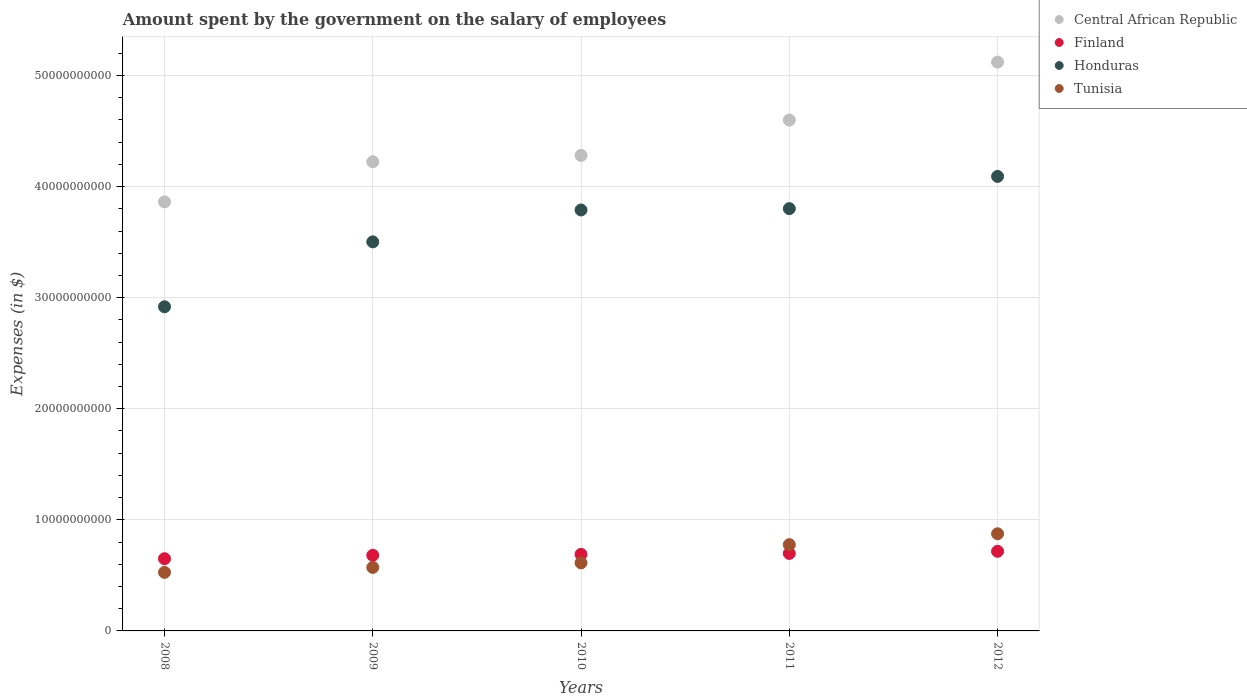How many different coloured dotlines are there?
Provide a succinct answer. 4. Is the number of dotlines equal to the number of legend labels?
Give a very brief answer. Yes. What is the amount spent on the salary of employees by the government in Tunisia in 2011?
Your answer should be very brief. 7.77e+09. Across all years, what is the maximum amount spent on the salary of employees by the government in Tunisia?
Your answer should be very brief. 8.75e+09. Across all years, what is the minimum amount spent on the salary of employees by the government in Honduras?
Your response must be concise. 2.92e+1. In which year was the amount spent on the salary of employees by the government in Tunisia maximum?
Keep it short and to the point. 2012. In which year was the amount spent on the salary of employees by the government in Central African Republic minimum?
Your answer should be compact. 2008. What is the total amount spent on the salary of employees by the government in Central African Republic in the graph?
Offer a very short reply. 2.21e+11. What is the difference between the amount spent on the salary of employees by the government in Finland in 2008 and that in 2012?
Offer a terse response. -6.66e+08. What is the difference between the amount spent on the salary of employees by the government in Finland in 2012 and the amount spent on the salary of employees by the government in Tunisia in 2010?
Offer a terse response. 1.04e+09. What is the average amount spent on the salary of employees by the government in Finland per year?
Your answer should be compact. 6.87e+09. In the year 2009, what is the difference between the amount spent on the salary of employees by the government in Central African Republic and amount spent on the salary of employees by the government in Tunisia?
Offer a very short reply. 3.65e+1. In how many years, is the amount spent on the salary of employees by the government in Finland greater than 14000000000 $?
Provide a succinct answer. 0. What is the ratio of the amount spent on the salary of employees by the government in Honduras in 2008 to that in 2009?
Your response must be concise. 0.83. Is the amount spent on the salary of employees by the government in Honduras in 2009 less than that in 2010?
Give a very brief answer. Yes. Is the difference between the amount spent on the salary of employees by the government in Central African Republic in 2008 and 2012 greater than the difference between the amount spent on the salary of employees by the government in Tunisia in 2008 and 2012?
Offer a terse response. No. What is the difference between the highest and the second highest amount spent on the salary of employees by the government in Tunisia?
Keep it short and to the point. 9.78e+08. What is the difference between the highest and the lowest amount spent on the salary of employees by the government in Honduras?
Keep it short and to the point. 1.17e+1. Is the sum of the amount spent on the salary of employees by the government in Central African Republic in 2009 and 2012 greater than the maximum amount spent on the salary of employees by the government in Finland across all years?
Ensure brevity in your answer.  Yes. Is the amount spent on the salary of employees by the government in Finland strictly less than the amount spent on the salary of employees by the government in Central African Republic over the years?
Make the answer very short. Yes. What is the difference between two consecutive major ticks on the Y-axis?
Ensure brevity in your answer.  1.00e+1. Does the graph contain grids?
Your answer should be very brief. Yes. Where does the legend appear in the graph?
Offer a very short reply. Top right. What is the title of the graph?
Your answer should be compact. Amount spent by the government on the salary of employees. Does "Senegal" appear as one of the legend labels in the graph?
Ensure brevity in your answer.  No. What is the label or title of the Y-axis?
Offer a terse response. Expenses (in $). What is the Expenses (in $) in Central African Republic in 2008?
Keep it short and to the point. 3.86e+1. What is the Expenses (in $) of Finland in 2008?
Your answer should be very brief. 6.50e+09. What is the Expenses (in $) of Honduras in 2008?
Keep it short and to the point. 2.92e+1. What is the Expenses (in $) in Tunisia in 2008?
Provide a short and direct response. 5.27e+09. What is the Expenses (in $) of Central African Republic in 2009?
Your answer should be very brief. 4.22e+1. What is the Expenses (in $) of Finland in 2009?
Offer a very short reply. 6.81e+09. What is the Expenses (in $) in Honduras in 2009?
Give a very brief answer. 3.50e+1. What is the Expenses (in $) of Tunisia in 2009?
Provide a short and direct response. 5.72e+09. What is the Expenses (in $) of Central African Republic in 2010?
Provide a short and direct response. 4.28e+1. What is the Expenses (in $) of Finland in 2010?
Give a very brief answer. 6.89e+09. What is the Expenses (in $) in Honduras in 2010?
Your response must be concise. 3.79e+1. What is the Expenses (in $) in Tunisia in 2010?
Ensure brevity in your answer.  6.13e+09. What is the Expenses (in $) of Central African Republic in 2011?
Your answer should be compact. 4.60e+1. What is the Expenses (in $) in Finland in 2011?
Keep it short and to the point. 6.98e+09. What is the Expenses (in $) of Honduras in 2011?
Your answer should be very brief. 3.80e+1. What is the Expenses (in $) in Tunisia in 2011?
Your answer should be very brief. 7.77e+09. What is the Expenses (in $) in Central African Republic in 2012?
Offer a very short reply. 5.12e+1. What is the Expenses (in $) in Finland in 2012?
Your response must be concise. 7.17e+09. What is the Expenses (in $) in Honduras in 2012?
Your answer should be very brief. 4.09e+1. What is the Expenses (in $) of Tunisia in 2012?
Your answer should be very brief. 8.75e+09. Across all years, what is the maximum Expenses (in $) in Central African Republic?
Ensure brevity in your answer.  5.12e+1. Across all years, what is the maximum Expenses (in $) in Finland?
Give a very brief answer. 7.17e+09. Across all years, what is the maximum Expenses (in $) of Honduras?
Give a very brief answer. 4.09e+1. Across all years, what is the maximum Expenses (in $) of Tunisia?
Your answer should be compact. 8.75e+09. Across all years, what is the minimum Expenses (in $) of Central African Republic?
Provide a succinct answer. 3.86e+1. Across all years, what is the minimum Expenses (in $) of Finland?
Provide a succinct answer. 6.50e+09. Across all years, what is the minimum Expenses (in $) of Honduras?
Provide a short and direct response. 2.92e+1. Across all years, what is the minimum Expenses (in $) of Tunisia?
Offer a terse response. 5.27e+09. What is the total Expenses (in $) in Central African Republic in the graph?
Offer a very short reply. 2.21e+11. What is the total Expenses (in $) in Finland in the graph?
Your response must be concise. 3.43e+1. What is the total Expenses (in $) in Honduras in the graph?
Give a very brief answer. 1.81e+11. What is the total Expenses (in $) of Tunisia in the graph?
Your answer should be compact. 3.36e+1. What is the difference between the Expenses (in $) in Central African Republic in 2008 and that in 2009?
Your answer should be compact. -3.62e+09. What is the difference between the Expenses (in $) in Finland in 2008 and that in 2009?
Provide a short and direct response. -3.06e+08. What is the difference between the Expenses (in $) in Honduras in 2008 and that in 2009?
Your answer should be compact. -5.85e+09. What is the difference between the Expenses (in $) of Tunisia in 2008 and that in 2009?
Provide a succinct answer. -4.45e+08. What is the difference between the Expenses (in $) of Central African Republic in 2008 and that in 2010?
Your answer should be compact. -4.18e+09. What is the difference between the Expenses (in $) of Finland in 2008 and that in 2010?
Offer a very short reply. -3.93e+08. What is the difference between the Expenses (in $) of Honduras in 2008 and that in 2010?
Provide a short and direct response. -8.72e+09. What is the difference between the Expenses (in $) in Tunisia in 2008 and that in 2010?
Your answer should be compact. -8.54e+08. What is the difference between the Expenses (in $) in Central African Republic in 2008 and that in 2011?
Provide a short and direct response. -7.37e+09. What is the difference between the Expenses (in $) of Finland in 2008 and that in 2011?
Give a very brief answer. -4.76e+08. What is the difference between the Expenses (in $) in Honduras in 2008 and that in 2011?
Keep it short and to the point. -8.84e+09. What is the difference between the Expenses (in $) in Tunisia in 2008 and that in 2011?
Provide a short and direct response. -2.50e+09. What is the difference between the Expenses (in $) in Central African Republic in 2008 and that in 2012?
Keep it short and to the point. -1.26e+1. What is the difference between the Expenses (in $) in Finland in 2008 and that in 2012?
Offer a very short reply. -6.66e+08. What is the difference between the Expenses (in $) in Honduras in 2008 and that in 2012?
Ensure brevity in your answer.  -1.17e+1. What is the difference between the Expenses (in $) of Tunisia in 2008 and that in 2012?
Your response must be concise. -3.47e+09. What is the difference between the Expenses (in $) of Central African Republic in 2009 and that in 2010?
Ensure brevity in your answer.  -5.67e+08. What is the difference between the Expenses (in $) of Finland in 2009 and that in 2010?
Provide a succinct answer. -8.70e+07. What is the difference between the Expenses (in $) in Honduras in 2009 and that in 2010?
Offer a very short reply. -2.87e+09. What is the difference between the Expenses (in $) of Tunisia in 2009 and that in 2010?
Provide a short and direct response. -4.09e+08. What is the difference between the Expenses (in $) in Central African Republic in 2009 and that in 2011?
Provide a short and direct response. -3.75e+09. What is the difference between the Expenses (in $) of Finland in 2009 and that in 2011?
Keep it short and to the point. -1.70e+08. What is the difference between the Expenses (in $) in Honduras in 2009 and that in 2011?
Ensure brevity in your answer.  -2.99e+09. What is the difference between the Expenses (in $) of Tunisia in 2009 and that in 2011?
Give a very brief answer. -2.05e+09. What is the difference between the Expenses (in $) in Central African Republic in 2009 and that in 2012?
Your answer should be compact. -8.97e+09. What is the difference between the Expenses (in $) of Finland in 2009 and that in 2012?
Offer a very short reply. -3.60e+08. What is the difference between the Expenses (in $) of Honduras in 2009 and that in 2012?
Your response must be concise. -5.89e+09. What is the difference between the Expenses (in $) of Tunisia in 2009 and that in 2012?
Keep it short and to the point. -3.03e+09. What is the difference between the Expenses (in $) in Central African Republic in 2010 and that in 2011?
Ensure brevity in your answer.  -3.18e+09. What is the difference between the Expenses (in $) in Finland in 2010 and that in 2011?
Keep it short and to the point. -8.30e+07. What is the difference between the Expenses (in $) in Honduras in 2010 and that in 2011?
Make the answer very short. -1.22e+08. What is the difference between the Expenses (in $) of Tunisia in 2010 and that in 2011?
Your response must be concise. -1.64e+09. What is the difference between the Expenses (in $) of Central African Republic in 2010 and that in 2012?
Your answer should be very brief. -8.40e+09. What is the difference between the Expenses (in $) in Finland in 2010 and that in 2012?
Give a very brief answer. -2.73e+08. What is the difference between the Expenses (in $) of Honduras in 2010 and that in 2012?
Keep it short and to the point. -3.02e+09. What is the difference between the Expenses (in $) of Tunisia in 2010 and that in 2012?
Your answer should be very brief. -2.62e+09. What is the difference between the Expenses (in $) of Central African Republic in 2011 and that in 2012?
Offer a very short reply. -5.22e+09. What is the difference between the Expenses (in $) of Finland in 2011 and that in 2012?
Provide a succinct answer. -1.90e+08. What is the difference between the Expenses (in $) of Honduras in 2011 and that in 2012?
Make the answer very short. -2.90e+09. What is the difference between the Expenses (in $) of Tunisia in 2011 and that in 2012?
Give a very brief answer. -9.78e+08. What is the difference between the Expenses (in $) in Central African Republic in 2008 and the Expenses (in $) in Finland in 2009?
Provide a short and direct response. 3.18e+1. What is the difference between the Expenses (in $) in Central African Republic in 2008 and the Expenses (in $) in Honduras in 2009?
Keep it short and to the point. 3.60e+09. What is the difference between the Expenses (in $) in Central African Republic in 2008 and the Expenses (in $) in Tunisia in 2009?
Ensure brevity in your answer.  3.29e+1. What is the difference between the Expenses (in $) of Finland in 2008 and the Expenses (in $) of Honduras in 2009?
Make the answer very short. -2.85e+1. What is the difference between the Expenses (in $) in Finland in 2008 and the Expenses (in $) in Tunisia in 2009?
Your response must be concise. 7.82e+08. What is the difference between the Expenses (in $) of Honduras in 2008 and the Expenses (in $) of Tunisia in 2009?
Keep it short and to the point. 2.35e+1. What is the difference between the Expenses (in $) in Central African Republic in 2008 and the Expenses (in $) in Finland in 2010?
Provide a succinct answer. 3.17e+1. What is the difference between the Expenses (in $) of Central African Republic in 2008 and the Expenses (in $) of Honduras in 2010?
Ensure brevity in your answer.  7.27e+08. What is the difference between the Expenses (in $) in Central African Republic in 2008 and the Expenses (in $) in Tunisia in 2010?
Your response must be concise. 3.25e+1. What is the difference between the Expenses (in $) of Finland in 2008 and the Expenses (in $) of Honduras in 2010?
Provide a short and direct response. -3.14e+1. What is the difference between the Expenses (in $) of Finland in 2008 and the Expenses (in $) of Tunisia in 2010?
Offer a terse response. 3.73e+08. What is the difference between the Expenses (in $) in Honduras in 2008 and the Expenses (in $) in Tunisia in 2010?
Your answer should be very brief. 2.31e+1. What is the difference between the Expenses (in $) of Central African Republic in 2008 and the Expenses (in $) of Finland in 2011?
Offer a terse response. 3.16e+1. What is the difference between the Expenses (in $) of Central African Republic in 2008 and the Expenses (in $) of Honduras in 2011?
Keep it short and to the point. 6.05e+08. What is the difference between the Expenses (in $) of Central African Republic in 2008 and the Expenses (in $) of Tunisia in 2011?
Ensure brevity in your answer.  3.09e+1. What is the difference between the Expenses (in $) of Finland in 2008 and the Expenses (in $) of Honduras in 2011?
Ensure brevity in your answer.  -3.15e+1. What is the difference between the Expenses (in $) in Finland in 2008 and the Expenses (in $) in Tunisia in 2011?
Your response must be concise. -1.27e+09. What is the difference between the Expenses (in $) of Honduras in 2008 and the Expenses (in $) of Tunisia in 2011?
Make the answer very short. 2.14e+1. What is the difference between the Expenses (in $) of Central African Republic in 2008 and the Expenses (in $) of Finland in 2012?
Ensure brevity in your answer.  3.15e+1. What is the difference between the Expenses (in $) of Central African Republic in 2008 and the Expenses (in $) of Honduras in 2012?
Your response must be concise. -2.29e+09. What is the difference between the Expenses (in $) in Central African Republic in 2008 and the Expenses (in $) in Tunisia in 2012?
Give a very brief answer. 2.99e+1. What is the difference between the Expenses (in $) in Finland in 2008 and the Expenses (in $) in Honduras in 2012?
Offer a very short reply. -3.44e+1. What is the difference between the Expenses (in $) of Finland in 2008 and the Expenses (in $) of Tunisia in 2012?
Your answer should be very brief. -2.25e+09. What is the difference between the Expenses (in $) in Honduras in 2008 and the Expenses (in $) in Tunisia in 2012?
Offer a terse response. 2.04e+1. What is the difference between the Expenses (in $) in Central African Republic in 2009 and the Expenses (in $) in Finland in 2010?
Your answer should be compact. 3.54e+1. What is the difference between the Expenses (in $) of Central African Republic in 2009 and the Expenses (in $) of Honduras in 2010?
Ensure brevity in your answer.  4.34e+09. What is the difference between the Expenses (in $) of Central African Republic in 2009 and the Expenses (in $) of Tunisia in 2010?
Offer a terse response. 3.61e+1. What is the difference between the Expenses (in $) in Finland in 2009 and the Expenses (in $) in Honduras in 2010?
Your answer should be compact. -3.11e+1. What is the difference between the Expenses (in $) of Finland in 2009 and the Expenses (in $) of Tunisia in 2010?
Provide a succinct answer. 6.79e+08. What is the difference between the Expenses (in $) in Honduras in 2009 and the Expenses (in $) in Tunisia in 2010?
Provide a short and direct response. 2.89e+1. What is the difference between the Expenses (in $) in Central African Republic in 2009 and the Expenses (in $) in Finland in 2011?
Keep it short and to the point. 3.53e+1. What is the difference between the Expenses (in $) in Central African Republic in 2009 and the Expenses (in $) in Honduras in 2011?
Keep it short and to the point. 4.22e+09. What is the difference between the Expenses (in $) in Central African Republic in 2009 and the Expenses (in $) in Tunisia in 2011?
Offer a very short reply. 3.45e+1. What is the difference between the Expenses (in $) in Finland in 2009 and the Expenses (in $) in Honduras in 2011?
Ensure brevity in your answer.  -3.12e+1. What is the difference between the Expenses (in $) in Finland in 2009 and the Expenses (in $) in Tunisia in 2011?
Provide a short and direct response. -9.62e+08. What is the difference between the Expenses (in $) of Honduras in 2009 and the Expenses (in $) of Tunisia in 2011?
Ensure brevity in your answer.  2.73e+1. What is the difference between the Expenses (in $) in Central African Republic in 2009 and the Expenses (in $) in Finland in 2012?
Your response must be concise. 3.51e+1. What is the difference between the Expenses (in $) of Central African Republic in 2009 and the Expenses (in $) of Honduras in 2012?
Keep it short and to the point. 1.32e+09. What is the difference between the Expenses (in $) of Central African Republic in 2009 and the Expenses (in $) of Tunisia in 2012?
Offer a very short reply. 3.35e+1. What is the difference between the Expenses (in $) of Finland in 2009 and the Expenses (in $) of Honduras in 2012?
Make the answer very short. -3.41e+1. What is the difference between the Expenses (in $) of Finland in 2009 and the Expenses (in $) of Tunisia in 2012?
Your answer should be very brief. -1.94e+09. What is the difference between the Expenses (in $) of Honduras in 2009 and the Expenses (in $) of Tunisia in 2012?
Give a very brief answer. 2.63e+1. What is the difference between the Expenses (in $) in Central African Republic in 2010 and the Expenses (in $) in Finland in 2011?
Your response must be concise. 3.58e+1. What is the difference between the Expenses (in $) in Central African Republic in 2010 and the Expenses (in $) in Honduras in 2011?
Give a very brief answer. 4.79e+09. What is the difference between the Expenses (in $) in Central African Republic in 2010 and the Expenses (in $) in Tunisia in 2011?
Your answer should be very brief. 3.50e+1. What is the difference between the Expenses (in $) of Finland in 2010 and the Expenses (in $) of Honduras in 2011?
Provide a succinct answer. -3.11e+1. What is the difference between the Expenses (in $) in Finland in 2010 and the Expenses (in $) in Tunisia in 2011?
Your answer should be compact. -8.75e+08. What is the difference between the Expenses (in $) of Honduras in 2010 and the Expenses (in $) of Tunisia in 2011?
Your answer should be very brief. 3.01e+1. What is the difference between the Expenses (in $) of Central African Republic in 2010 and the Expenses (in $) of Finland in 2012?
Keep it short and to the point. 3.56e+1. What is the difference between the Expenses (in $) of Central African Republic in 2010 and the Expenses (in $) of Honduras in 2012?
Your answer should be compact. 1.89e+09. What is the difference between the Expenses (in $) of Central African Republic in 2010 and the Expenses (in $) of Tunisia in 2012?
Your answer should be compact. 3.41e+1. What is the difference between the Expenses (in $) in Finland in 2010 and the Expenses (in $) in Honduras in 2012?
Provide a short and direct response. -3.40e+1. What is the difference between the Expenses (in $) of Finland in 2010 and the Expenses (in $) of Tunisia in 2012?
Provide a short and direct response. -1.85e+09. What is the difference between the Expenses (in $) of Honduras in 2010 and the Expenses (in $) of Tunisia in 2012?
Provide a succinct answer. 2.92e+1. What is the difference between the Expenses (in $) in Central African Republic in 2011 and the Expenses (in $) in Finland in 2012?
Offer a terse response. 3.88e+1. What is the difference between the Expenses (in $) of Central African Republic in 2011 and the Expenses (in $) of Honduras in 2012?
Offer a very short reply. 5.07e+09. What is the difference between the Expenses (in $) in Central African Republic in 2011 and the Expenses (in $) in Tunisia in 2012?
Your response must be concise. 3.72e+1. What is the difference between the Expenses (in $) of Finland in 2011 and the Expenses (in $) of Honduras in 2012?
Make the answer very short. -3.39e+1. What is the difference between the Expenses (in $) of Finland in 2011 and the Expenses (in $) of Tunisia in 2012?
Offer a terse response. -1.77e+09. What is the difference between the Expenses (in $) of Honduras in 2011 and the Expenses (in $) of Tunisia in 2012?
Provide a short and direct response. 2.93e+1. What is the average Expenses (in $) of Central African Republic per year?
Your answer should be compact. 4.42e+1. What is the average Expenses (in $) in Finland per year?
Your answer should be compact. 6.87e+09. What is the average Expenses (in $) of Honduras per year?
Ensure brevity in your answer.  3.62e+1. What is the average Expenses (in $) of Tunisia per year?
Ensure brevity in your answer.  6.73e+09. In the year 2008, what is the difference between the Expenses (in $) in Central African Republic and Expenses (in $) in Finland?
Your answer should be very brief. 3.21e+1. In the year 2008, what is the difference between the Expenses (in $) of Central African Republic and Expenses (in $) of Honduras?
Offer a very short reply. 9.44e+09. In the year 2008, what is the difference between the Expenses (in $) in Central African Republic and Expenses (in $) in Tunisia?
Ensure brevity in your answer.  3.34e+1. In the year 2008, what is the difference between the Expenses (in $) of Finland and Expenses (in $) of Honduras?
Offer a terse response. -2.27e+1. In the year 2008, what is the difference between the Expenses (in $) of Finland and Expenses (in $) of Tunisia?
Keep it short and to the point. 1.23e+09. In the year 2008, what is the difference between the Expenses (in $) in Honduras and Expenses (in $) in Tunisia?
Provide a short and direct response. 2.39e+1. In the year 2009, what is the difference between the Expenses (in $) in Central African Republic and Expenses (in $) in Finland?
Offer a very short reply. 3.54e+1. In the year 2009, what is the difference between the Expenses (in $) of Central African Republic and Expenses (in $) of Honduras?
Your response must be concise. 7.22e+09. In the year 2009, what is the difference between the Expenses (in $) of Central African Republic and Expenses (in $) of Tunisia?
Keep it short and to the point. 3.65e+1. In the year 2009, what is the difference between the Expenses (in $) of Finland and Expenses (in $) of Honduras?
Your answer should be compact. -2.82e+1. In the year 2009, what is the difference between the Expenses (in $) of Finland and Expenses (in $) of Tunisia?
Your answer should be compact. 1.09e+09. In the year 2009, what is the difference between the Expenses (in $) of Honduras and Expenses (in $) of Tunisia?
Your answer should be very brief. 2.93e+1. In the year 2010, what is the difference between the Expenses (in $) of Central African Republic and Expenses (in $) of Finland?
Offer a very short reply. 3.59e+1. In the year 2010, what is the difference between the Expenses (in $) of Central African Republic and Expenses (in $) of Honduras?
Your response must be concise. 4.91e+09. In the year 2010, what is the difference between the Expenses (in $) of Central African Republic and Expenses (in $) of Tunisia?
Ensure brevity in your answer.  3.67e+1. In the year 2010, what is the difference between the Expenses (in $) in Finland and Expenses (in $) in Honduras?
Your answer should be compact. -3.10e+1. In the year 2010, what is the difference between the Expenses (in $) of Finland and Expenses (in $) of Tunisia?
Your answer should be very brief. 7.66e+08. In the year 2010, what is the difference between the Expenses (in $) in Honduras and Expenses (in $) in Tunisia?
Give a very brief answer. 3.18e+1. In the year 2011, what is the difference between the Expenses (in $) of Central African Republic and Expenses (in $) of Finland?
Provide a short and direct response. 3.90e+1. In the year 2011, what is the difference between the Expenses (in $) in Central African Republic and Expenses (in $) in Honduras?
Give a very brief answer. 7.97e+09. In the year 2011, what is the difference between the Expenses (in $) in Central African Republic and Expenses (in $) in Tunisia?
Give a very brief answer. 3.82e+1. In the year 2011, what is the difference between the Expenses (in $) of Finland and Expenses (in $) of Honduras?
Ensure brevity in your answer.  -3.10e+1. In the year 2011, what is the difference between the Expenses (in $) of Finland and Expenses (in $) of Tunisia?
Ensure brevity in your answer.  -7.92e+08. In the year 2011, what is the difference between the Expenses (in $) in Honduras and Expenses (in $) in Tunisia?
Keep it short and to the point. 3.03e+1. In the year 2012, what is the difference between the Expenses (in $) in Central African Republic and Expenses (in $) in Finland?
Provide a short and direct response. 4.40e+1. In the year 2012, what is the difference between the Expenses (in $) of Central African Republic and Expenses (in $) of Honduras?
Ensure brevity in your answer.  1.03e+1. In the year 2012, what is the difference between the Expenses (in $) of Central African Republic and Expenses (in $) of Tunisia?
Your answer should be very brief. 4.25e+1. In the year 2012, what is the difference between the Expenses (in $) of Finland and Expenses (in $) of Honduras?
Keep it short and to the point. -3.38e+1. In the year 2012, what is the difference between the Expenses (in $) in Finland and Expenses (in $) in Tunisia?
Keep it short and to the point. -1.58e+09. In the year 2012, what is the difference between the Expenses (in $) of Honduras and Expenses (in $) of Tunisia?
Your answer should be compact. 3.22e+1. What is the ratio of the Expenses (in $) of Central African Republic in 2008 to that in 2009?
Make the answer very short. 0.91. What is the ratio of the Expenses (in $) in Finland in 2008 to that in 2009?
Your answer should be compact. 0.95. What is the ratio of the Expenses (in $) in Honduras in 2008 to that in 2009?
Your answer should be compact. 0.83. What is the ratio of the Expenses (in $) of Tunisia in 2008 to that in 2009?
Offer a terse response. 0.92. What is the ratio of the Expenses (in $) of Central African Republic in 2008 to that in 2010?
Your answer should be very brief. 0.9. What is the ratio of the Expenses (in $) of Finland in 2008 to that in 2010?
Keep it short and to the point. 0.94. What is the ratio of the Expenses (in $) in Honduras in 2008 to that in 2010?
Your response must be concise. 0.77. What is the ratio of the Expenses (in $) of Tunisia in 2008 to that in 2010?
Your answer should be compact. 0.86. What is the ratio of the Expenses (in $) in Central African Republic in 2008 to that in 2011?
Ensure brevity in your answer.  0.84. What is the ratio of the Expenses (in $) of Finland in 2008 to that in 2011?
Offer a terse response. 0.93. What is the ratio of the Expenses (in $) of Honduras in 2008 to that in 2011?
Provide a short and direct response. 0.77. What is the ratio of the Expenses (in $) of Tunisia in 2008 to that in 2011?
Ensure brevity in your answer.  0.68. What is the ratio of the Expenses (in $) of Central African Republic in 2008 to that in 2012?
Your answer should be very brief. 0.75. What is the ratio of the Expenses (in $) of Finland in 2008 to that in 2012?
Your response must be concise. 0.91. What is the ratio of the Expenses (in $) in Honduras in 2008 to that in 2012?
Keep it short and to the point. 0.71. What is the ratio of the Expenses (in $) in Tunisia in 2008 to that in 2012?
Your answer should be very brief. 0.6. What is the ratio of the Expenses (in $) of Central African Republic in 2009 to that in 2010?
Your answer should be very brief. 0.99. What is the ratio of the Expenses (in $) of Finland in 2009 to that in 2010?
Your response must be concise. 0.99. What is the ratio of the Expenses (in $) in Honduras in 2009 to that in 2010?
Your answer should be compact. 0.92. What is the ratio of the Expenses (in $) in Tunisia in 2009 to that in 2010?
Offer a very short reply. 0.93. What is the ratio of the Expenses (in $) in Central African Republic in 2009 to that in 2011?
Provide a short and direct response. 0.92. What is the ratio of the Expenses (in $) of Finland in 2009 to that in 2011?
Your answer should be compact. 0.98. What is the ratio of the Expenses (in $) in Honduras in 2009 to that in 2011?
Your answer should be compact. 0.92. What is the ratio of the Expenses (in $) of Tunisia in 2009 to that in 2011?
Offer a terse response. 0.74. What is the ratio of the Expenses (in $) of Central African Republic in 2009 to that in 2012?
Offer a terse response. 0.82. What is the ratio of the Expenses (in $) of Finland in 2009 to that in 2012?
Make the answer very short. 0.95. What is the ratio of the Expenses (in $) of Honduras in 2009 to that in 2012?
Provide a short and direct response. 0.86. What is the ratio of the Expenses (in $) in Tunisia in 2009 to that in 2012?
Your answer should be compact. 0.65. What is the ratio of the Expenses (in $) of Central African Republic in 2010 to that in 2011?
Offer a terse response. 0.93. What is the ratio of the Expenses (in $) in Honduras in 2010 to that in 2011?
Your answer should be compact. 1. What is the ratio of the Expenses (in $) in Tunisia in 2010 to that in 2011?
Keep it short and to the point. 0.79. What is the ratio of the Expenses (in $) in Central African Republic in 2010 to that in 2012?
Provide a short and direct response. 0.84. What is the ratio of the Expenses (in $) of Finland in 2010 to that in 2012?
Your answer should be compact. 0.96. What is the ratio of the Expenses (in $) in Honduras in 2010 to that in 2012?
Your answer should be compact. 0.93. What is the ratio of the Expenses (in $) in Tunisia in 2010 to that in 2012?
Your answer should be compact. 0.7. What is the ratio of the Expenses (in $) in Central African Republic in 2011 to that in 2012?
Your answer should be very brief. 0.9. What is the ratio of the Expenses (in $) in Finland in 2011 to that in 2012?
Keep it short and to the point. 0.97. What is the ratio of the Expenses (in $) of Honduras in 2011 to that in 2012?
Give a very brief answer. 0.93. What is the ratio of the Expenses (in $) in Tunisia in 2011 to that in 2012?
Your answer should be compact. 0.89. What is the difference between the highest and the second highest Expenses (in $) in Central African Republic?
Your answer should be compact. 5.22e+09. What is the difference between the highest and the second highest Expenses (in $) in Finland?
Give a very brief answer. 1.90e+08. What is the difference between the highest and the second highest Expenses (in $) in Honduras?
Provide a short and direct response. 2.90e+09. What is the difference between the highest and the second highest Expenses (in $) of Tunisia?
Ensure brevity in your answer.  9.78e+08. What is the difference between the highest and the lowest Expenses (in $) in Central African Republic?
Give a very brief answer. 1.26e+1. What is the difference between the highest and the lowest Expenses (in $) of Finland?
Offer a very short reply. 6.66e+08. What is the difference between the highest and the lowest Expenses (in $) of Honduras?
Ensure brevity in your answer.  1.17e+1. What is the difference between the highest and the lowest Expenses (in $) of Tunisia?
Offer a very short reply. 3.47e+09. 